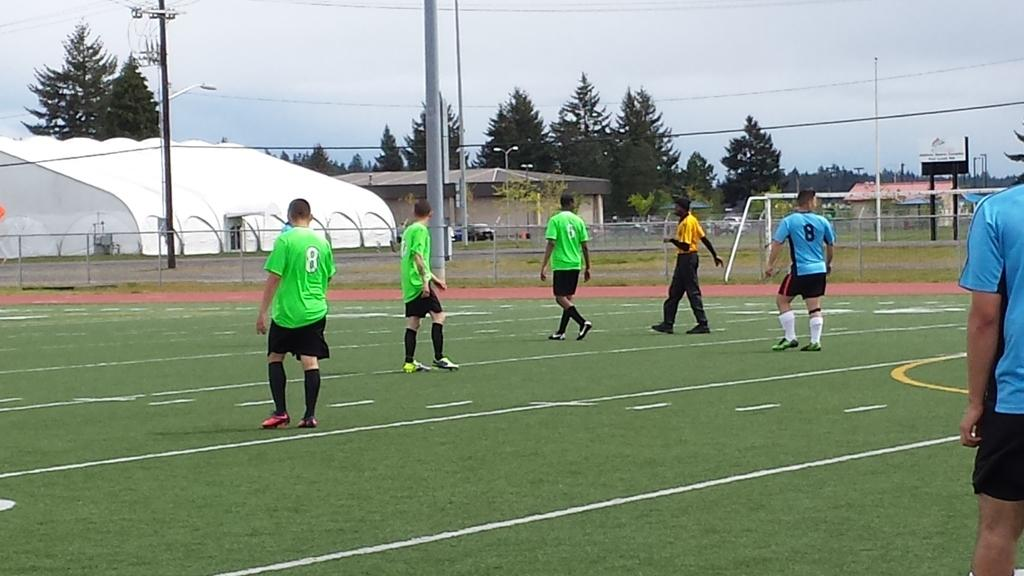<image>
Provide a brief description of the given image. Player number 8 wearing green stands near another player 8 wearing blue 